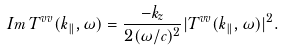<formula> <loc_0><loc_0><loc_500><loc_500>I m \, T ^ { v v } ( { k } _ { \| } , \omega ) = \frac { - k _ { z } } { 2 ( \omega / c ) ^ { 2 } } | T ^ { v v } ( { k } _ { \| } , \omega ) | ^ { 2 } .</formula> 